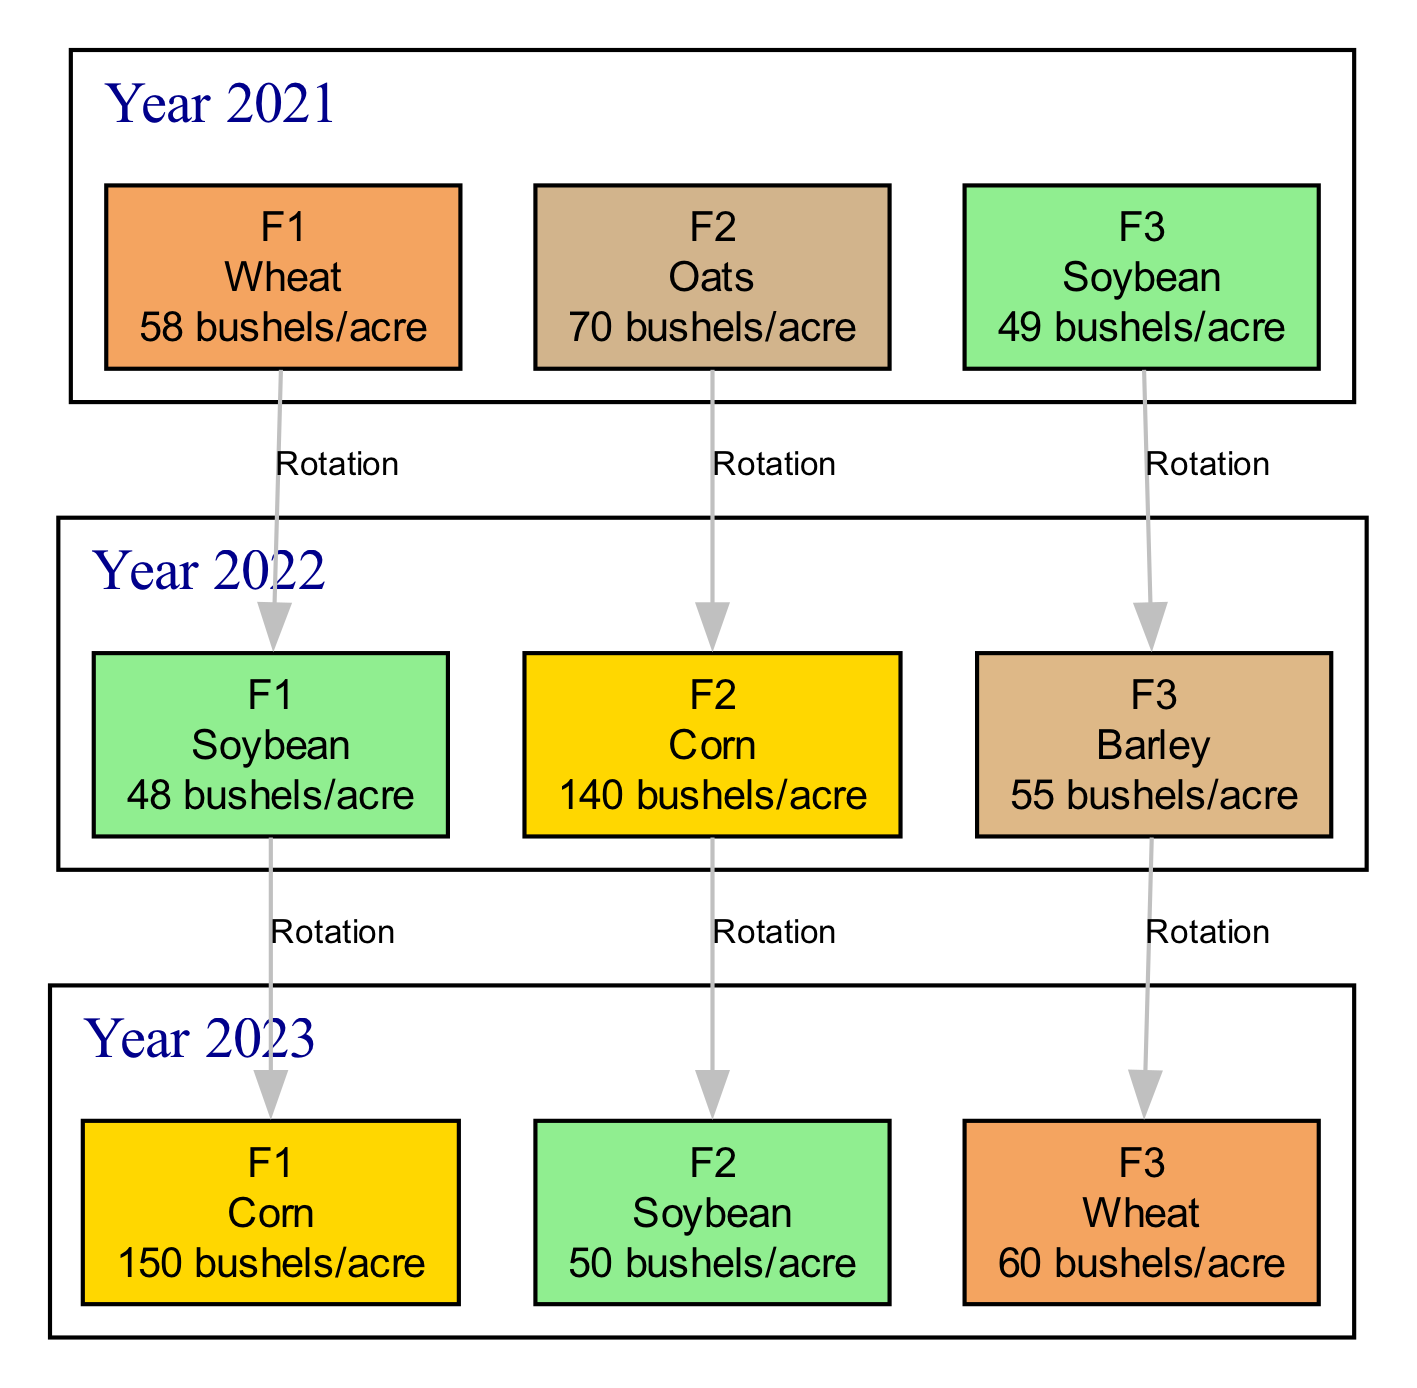What crop was planted in Field F1 in 2022? In the Planting History for Field F1, it shows that in 2022, the crop was Soybean.
Answer: Soybean What is the yield of Corn in 2023 from Field F2? Looking at the Crop Rotation for the year 2023 in Field F2, the yield for Corn is shown as 50 bushels/acre.
Answer: 50 bushels/acre How many different crops were grown in 2021? In the Crop Rotation for the year 2021, three different crops are mentioned: Wheat, Oats, and Soybean, making a total of three crops.
Answer: 3 What was the yield for Wheat in 2023? The Crop Rotation for 2023 indicates that the yield for Wheat is 60 bushels/acre in Field F3.
Answer: 60 bushels/acre Which crop is grown in Field F2 in the year 2021? Referring to the Planting History for Field F2, it indicates that Oats were planted in the year 2021, according to the provided data.
Answer: Oats What is the relationship between the crops grown in Field F3 in 2022 and 2021? From the Planting History, Field F3 shows that Barley was grown in 2022 and Soybean was grown in 2021, indicating a rotation from Soybean to Barley.
Answer: Rotation What crop rotation occurred in Field F1 from 2021 to 2023? In Field F1, Wheat was planted in 2021, followed by Soybean in 2022, and Corn in 2023. This indicates a sequential crop rotation from Wheat to Soybean to Corn.
Answer: Wheat to Soybean to Corn Which field had the highest yield for Soybean in 2022? The Crop Rotation data shows Field F2 had the highest yield for Soybean in 2022 with 50 bushels/acre compared to Field F1's 48 bushels/acre.
Answer: Field F2 How many edges are illustrated for Field F3 in the diagram? Evaluating the connections in the Crop Rotation, Field F3 has two rotations: from Soybean in 2021 to Barley in 2022 and to Wheat in 2023, creating a total of two edges.
Answer: 2 